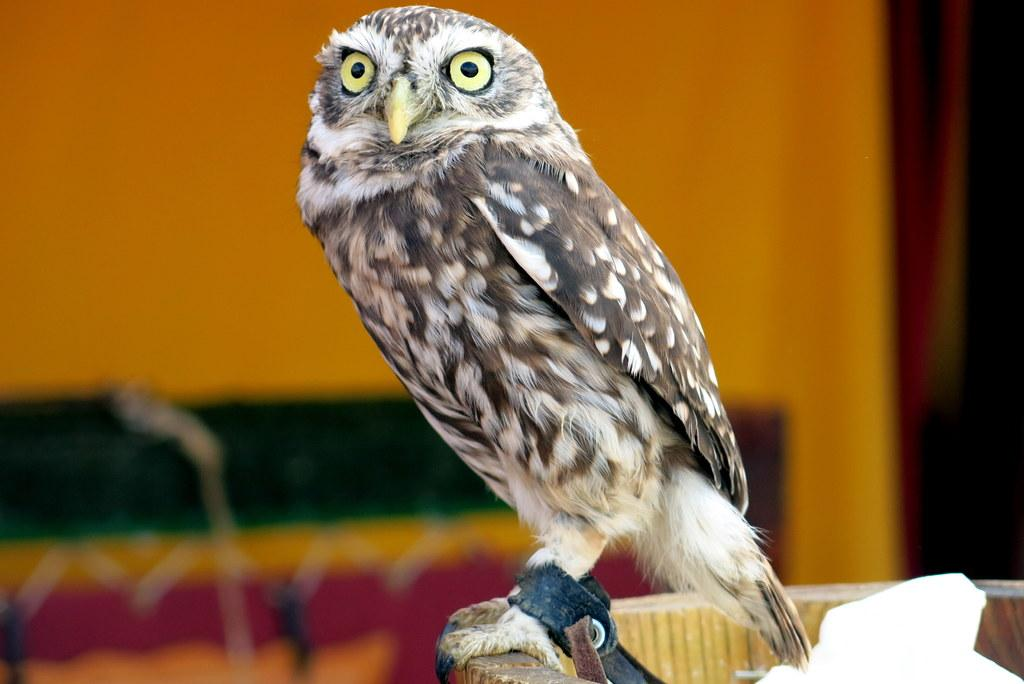What type of animal is in the image? There is an owl in the image. Where is the owl located in the image? The owl is sitting on a wall. Is the owl involved in any war-related activities in the image? There is no indication of any war-related activities in the image; it simply features an owl sitting on a wall. 